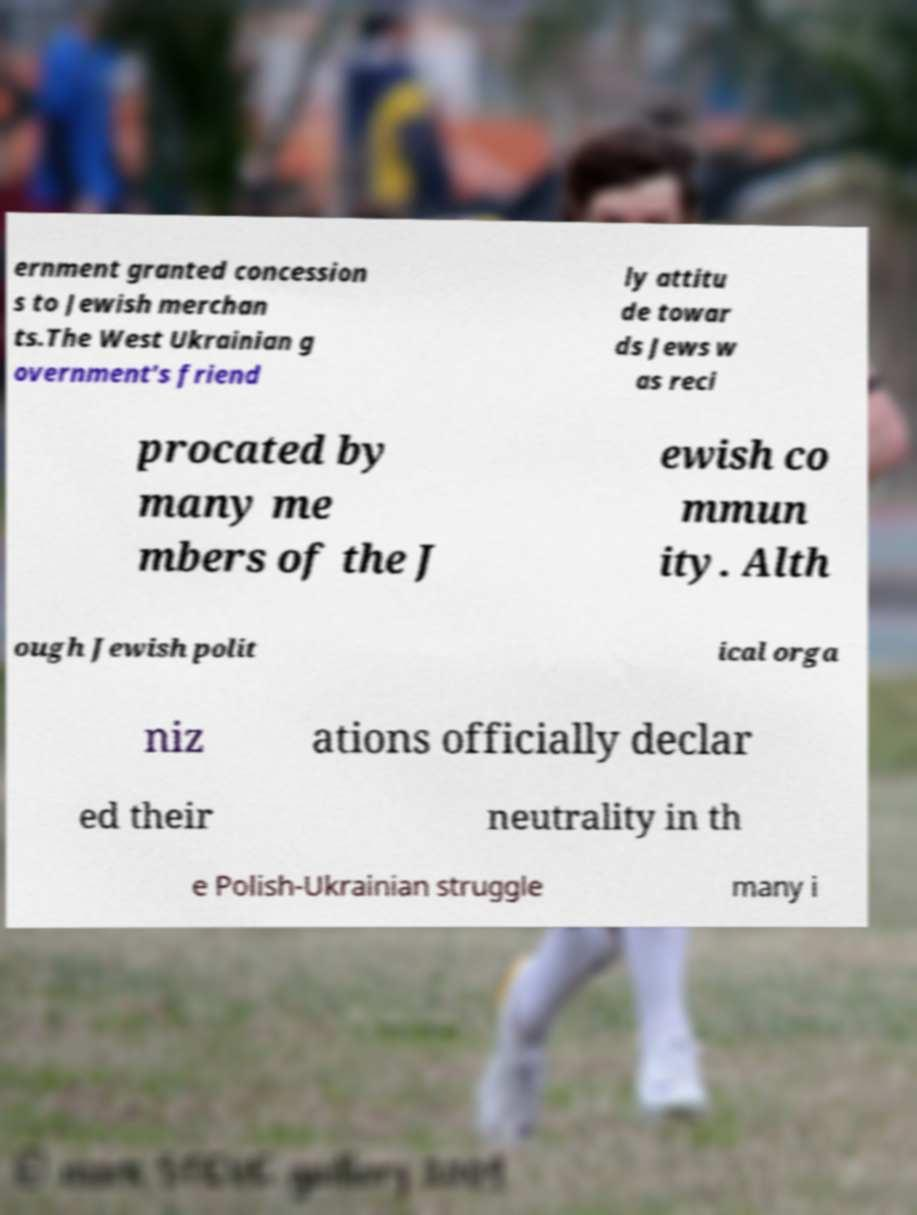For documentation purposes, I need the text within this image transcribed. Could you provide that? ernment granted concession s to Jewish merchan ts.The West Ukrainian g overnment's friend ly attitu de towar ds Jews w as reci procated by many me mbers of the J ewish co mmun ity. Alth ough Jewish polit ical orga niz ations officially declar ed their neutrality in th e Polish-Ukrainian struggle many i 